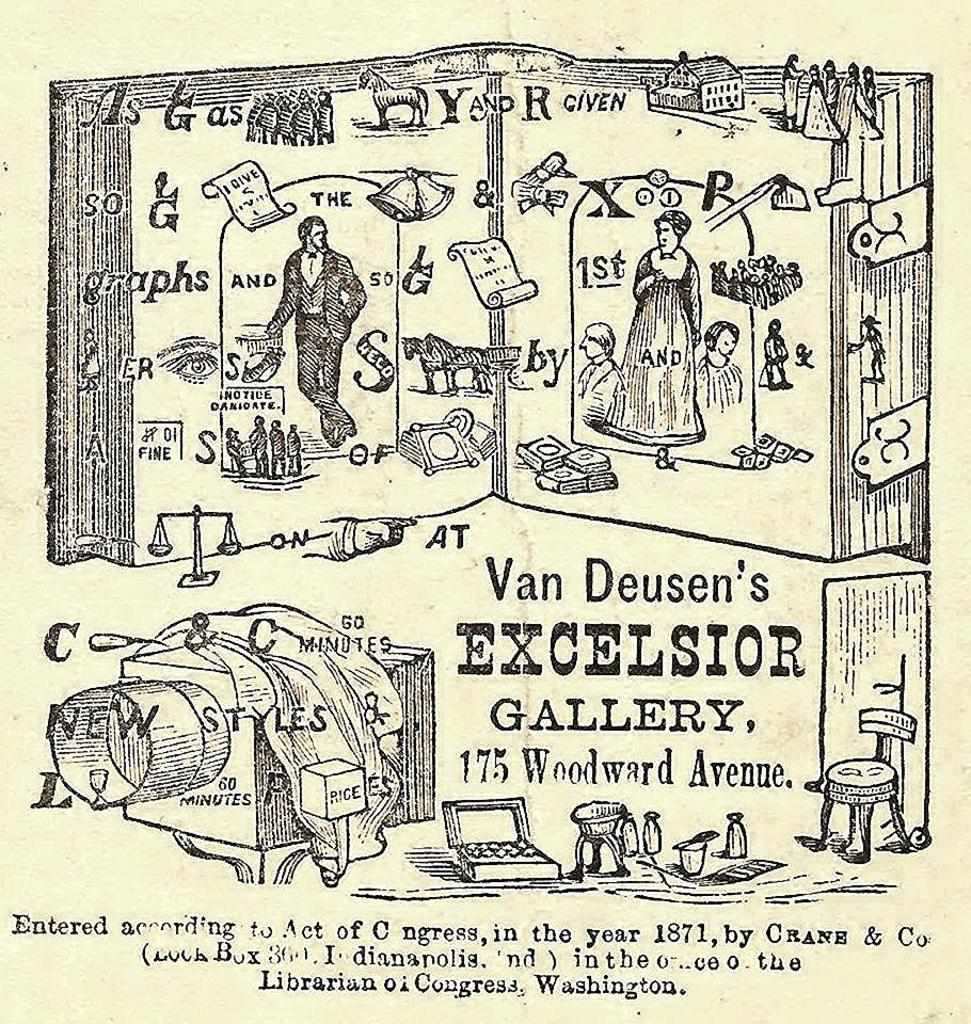In one or two sentences, can you explain what this image depicts? The image looks like a poster. In the image we can see text, people, bottles and various objects. 